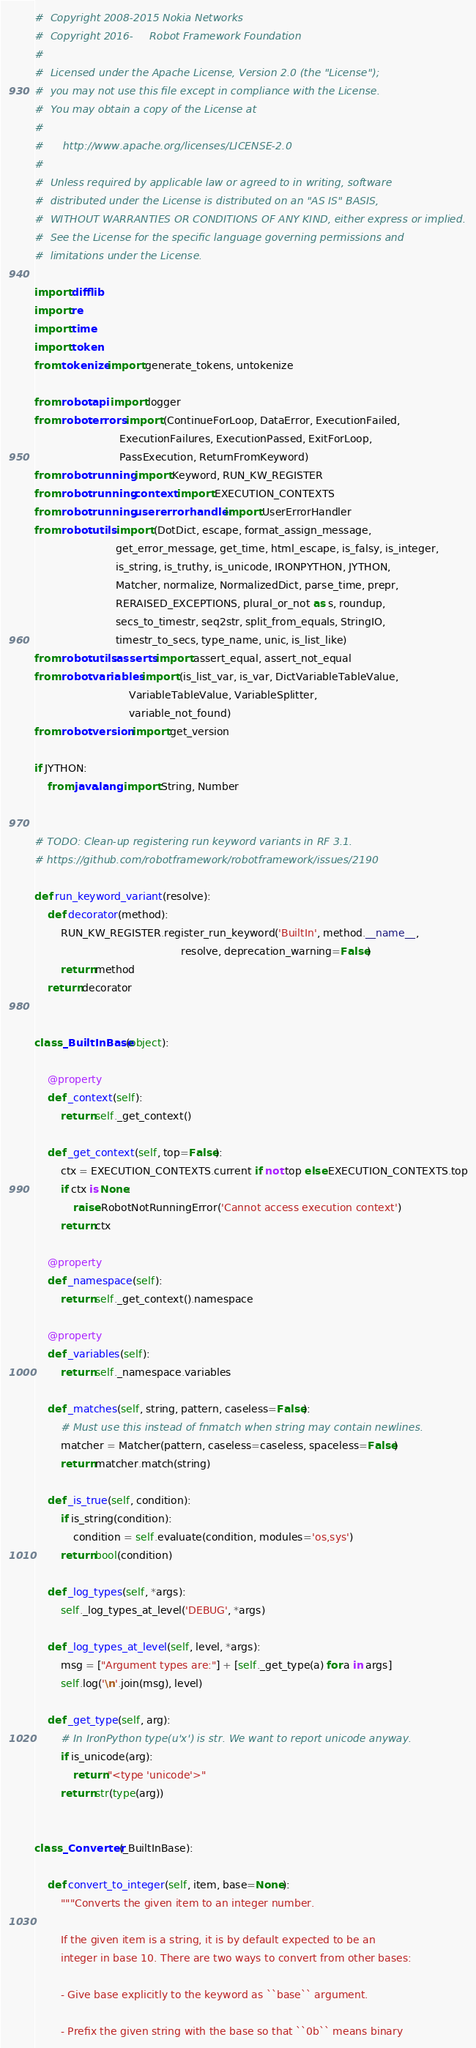<code> <loc_0><loc_0><loc_500><loc_500><_Python_>#  Copyright 2008-2015 Nokia Networks
#  Copyright 2016-     Robot Framework Foundation
#
#  Licensed under the Apache License, Version 2.0 (the "License");
#  you may not use this file except in compliance with the License.
#  You may obtain a copy of the License at
#
#      http://www.apache.org/licenses/LICENSE-2.0
#
#  Unless required by applicable law or agreed to in writing, software
#  distributed under the License is distributed on an "AS IS" BASIS,
#  WITHOUT WARRANTIES OR CONDITIONS OF ANY KIND, either express or implied.
#  See the License for the specific language governing permissions and
#  limitations under the License.

import difflib
import re
import time
import token
from tokenize import generate_tokens, untokenize

from robot.api import logger
from robot.errors import (ContinueForLoop, DataError, ExecutionFailed,
                          ExecutionFailures, ExecutionPassed, ExitForLoop,
                          PassExecution, ReturnFromKeyword)
from robot.running import Keyword, RUN_KW_REGISTER
from robot.running.context import EXECUTION_CONTEXTS
from robot.running.usererrorhandler import UserErrorHandler
from robot.utils import (DotDict, escape, format_assign_message,
                         get_error_message, get_time, html_escape, is_falsy, is_integer,
                         is_string, is_truthy, is_unicode, IRONPYTHON, JYTHON,
                         Matcher, normalize, NormalizedDict, parse_time, prepr,
                         RERAISED_EXCEPTIONS, plural_or_not as s, roundup,
                         secs_to_timestr, seq2str, split_from_equals, StringIO,
                         timestr_to_secs, type_name, unic, is_list_like)
from robot.utils.asserts import assert_equal, assert_not_equal
from robot.variables import (is_list_var, is_var, DictVariableTableValue,
                             VariableTableValue, VariableSplitter,
                             variable_not_found)
from robot.version import get_version

if JYTHON:
    from java.lang import String, Number


# TODO: Clean-up registering run keyword variants in RF 3.1.
# https://github.com/robotframework/robotframework/issues/2190

def run_keyword_variant(resolve):
    def decorator(method):
        RUN_KW_REGISTER.register_run_keyword('BuiltIn', method.__name__,
                                             resolve, deprecation_warning=False)
        return method
    return decorator


class _BuiltInBase(object):

    @property
    def _context(self):
        return self._get_context()

    def _get_context(self, top=False):
        ctx = EXECUTION_CONTEXTS.current if not top else EXECUTION_CONTEXTS.top
        if ctx is None:
            raise RobotNotRunningError('Cannot access execution context')
        return ctx

    @property
    def _namespace(self):
        return self._get_context().namespace

    @property
    def _variables(self):
        return self._namespace.variables

    def _matches(self, string, pattern, caseless=False):
        # Must use this instead of fnmatch when string may contain newlines.
        matcher = Matcher(pattern, caseless=caseless, spaceless=False)
        return matcher.match(string)

    def _is_true(self, condition):
        if is_string(condition):
            condition = self.evaluate(condition, modules='os,sys')
        return bool(condition)

    def _log_types(self, *args):
        self._log_types_at_level('DEBUG', *args)

    def _log_types_at_level(self, level, *args):
        msg = ["Argument types are:"] + [self._get_type(a) for a in args]
        self.log('\n'.join(msg), level)

    def _get_type(self, arg):
        # In IronPython type(u'x') is str. We want to report unicode anyway.
        if is_unicode(arg):
            return "<type 'unicode'>"
        return str(type(arg))


class _Converter(_BuiltInBase):

    def convert_to_integer(self, item, base=None):
        """Converts the given item to an integer number.

        If the given item is a string, it is by default expected to be an
        integer in base 10. There are two ways to convert from other bases:

        - Give base explicitly to the keyword as ``base`` argument.

        - Prefix the given string with the base so that ``0b`` means binary</code> 